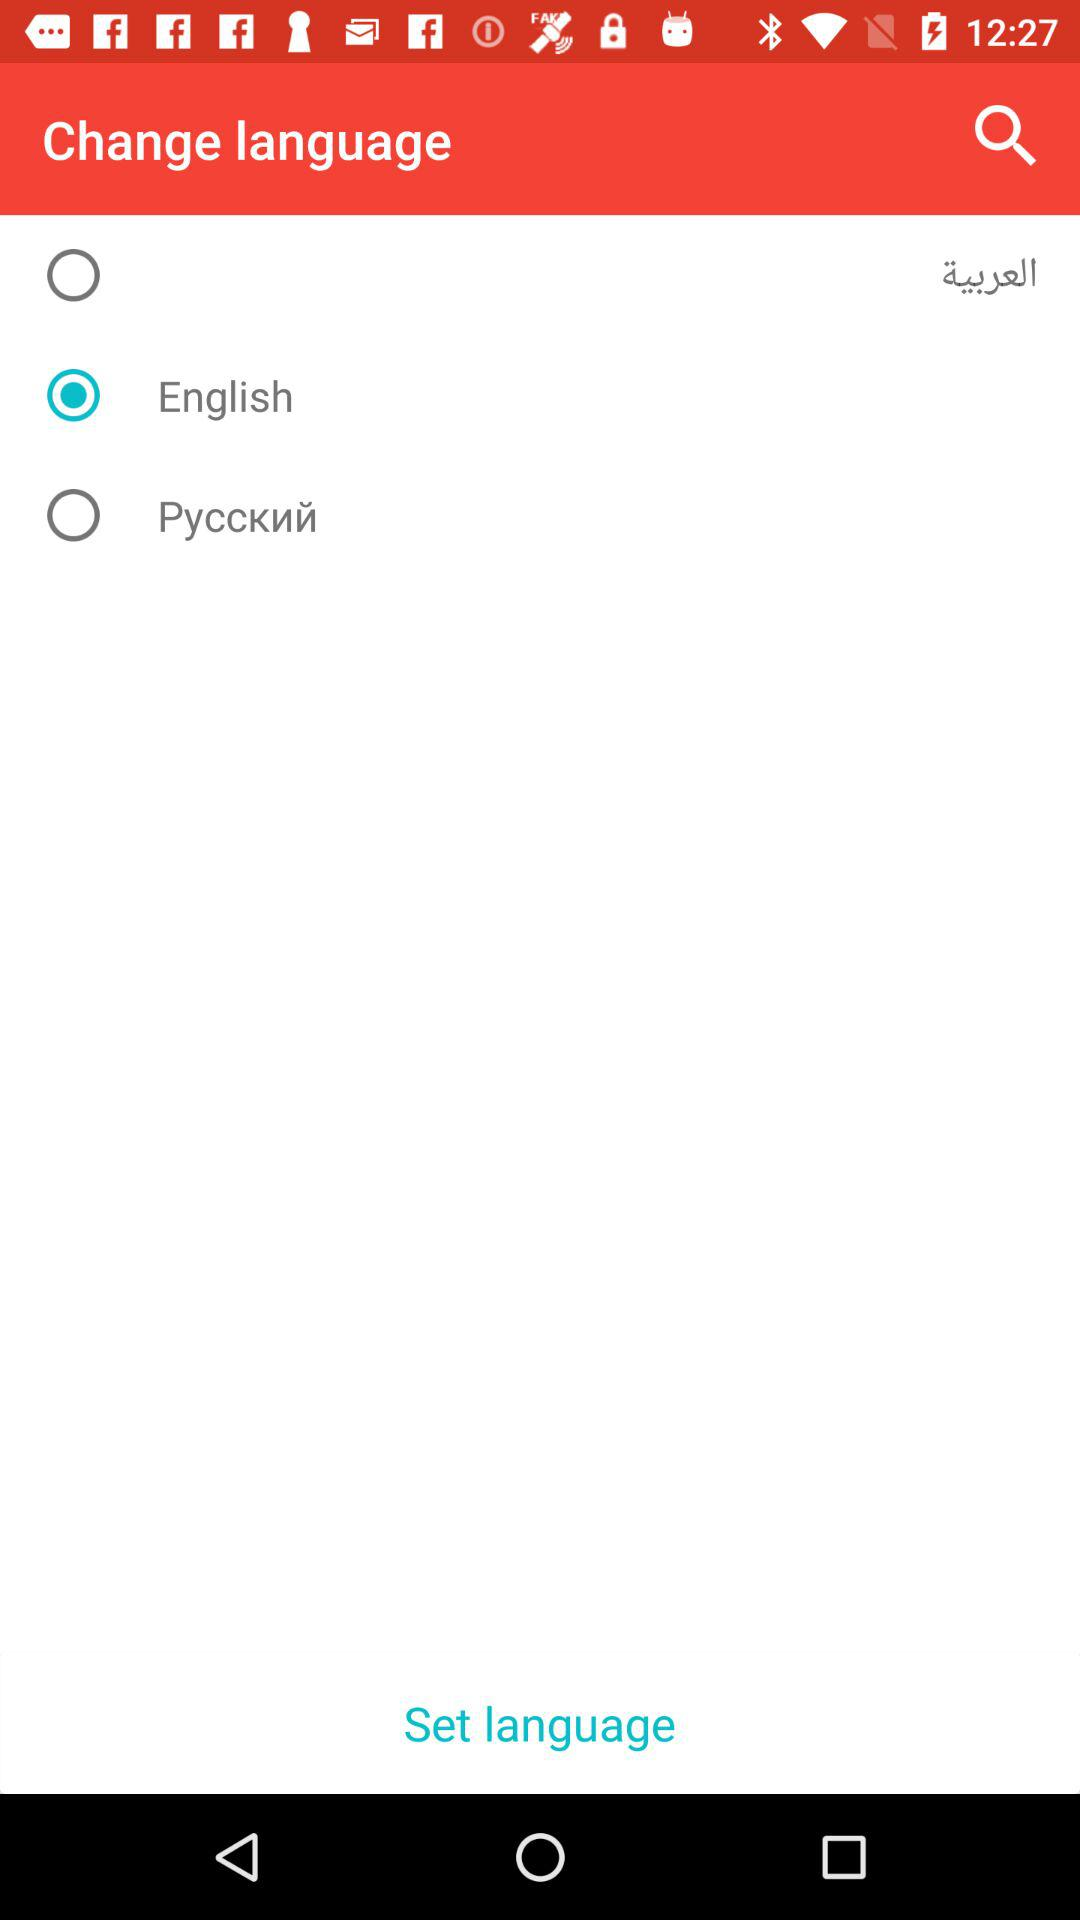How many languages are available to choose from?
Answer the question using a single word or phrase. 3 